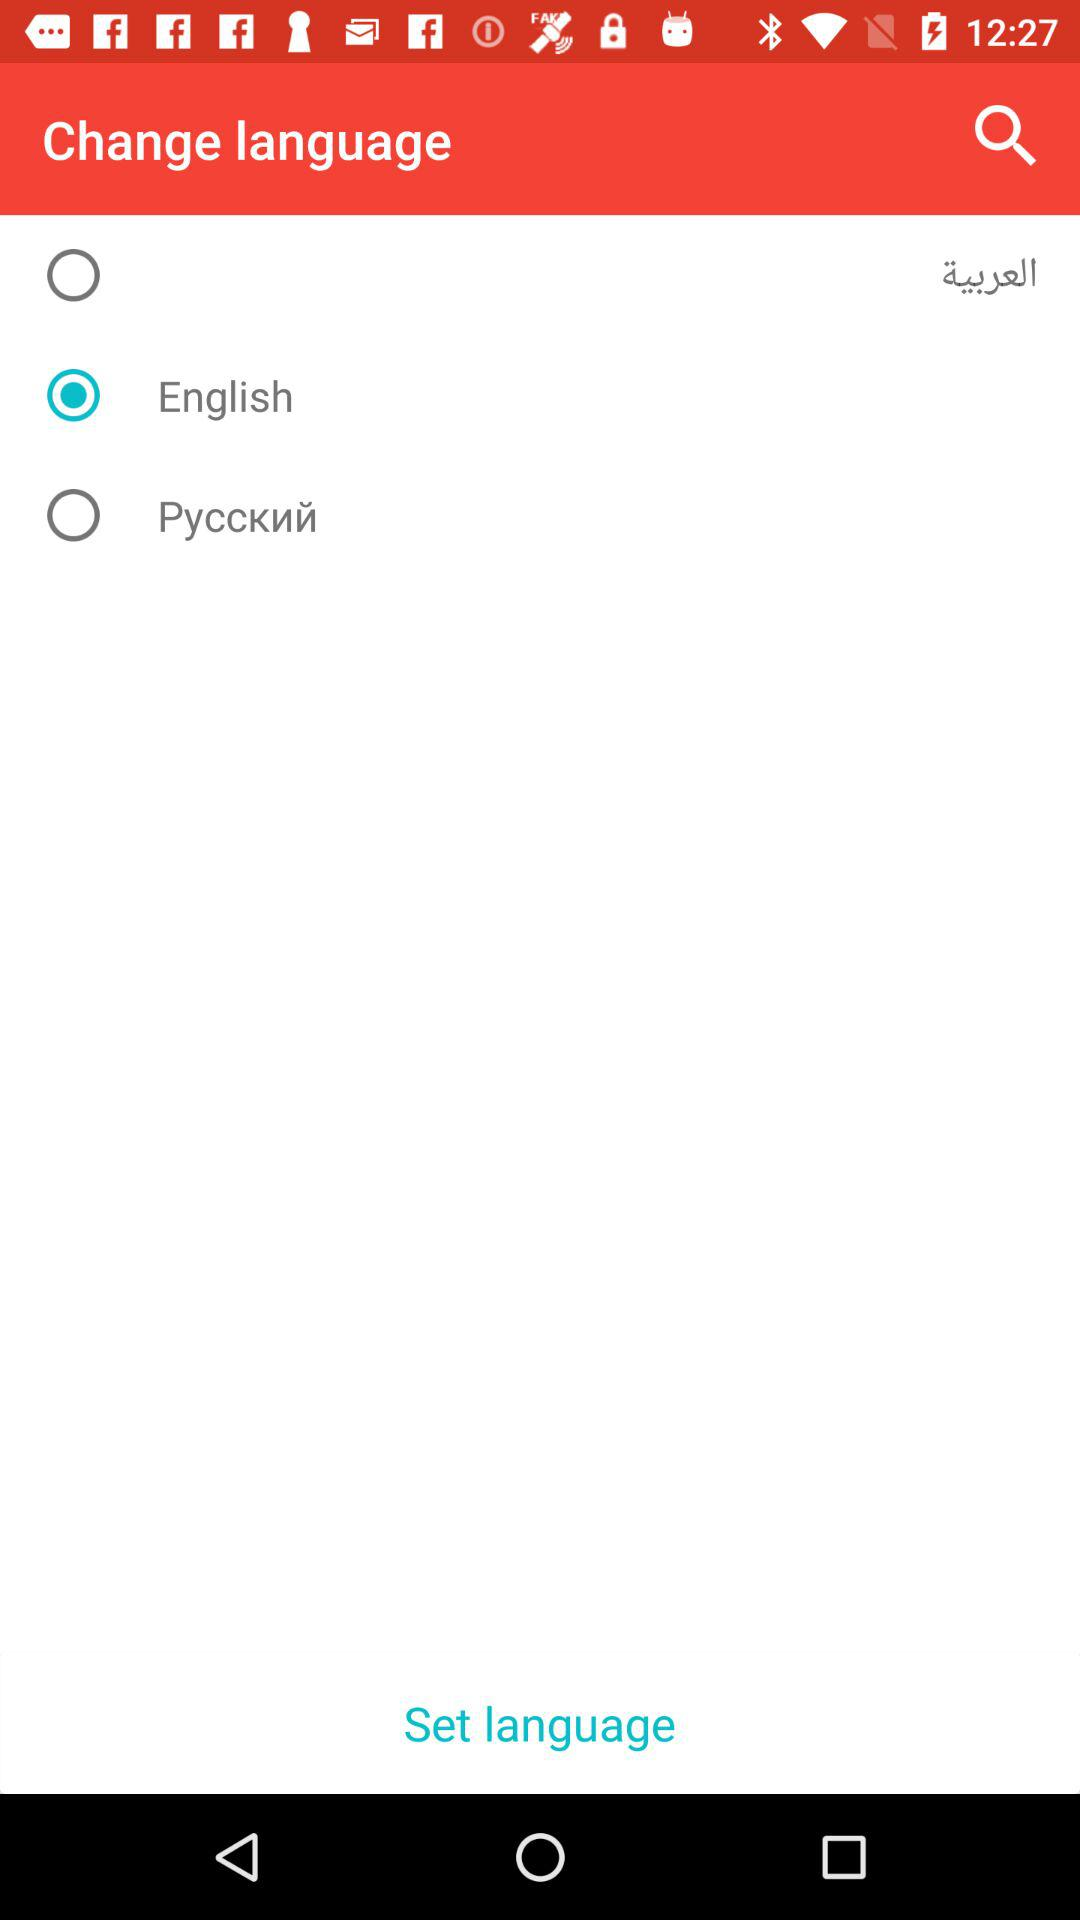How many languages are available to choose from?
Answer the question using a single word or phrase. 3 